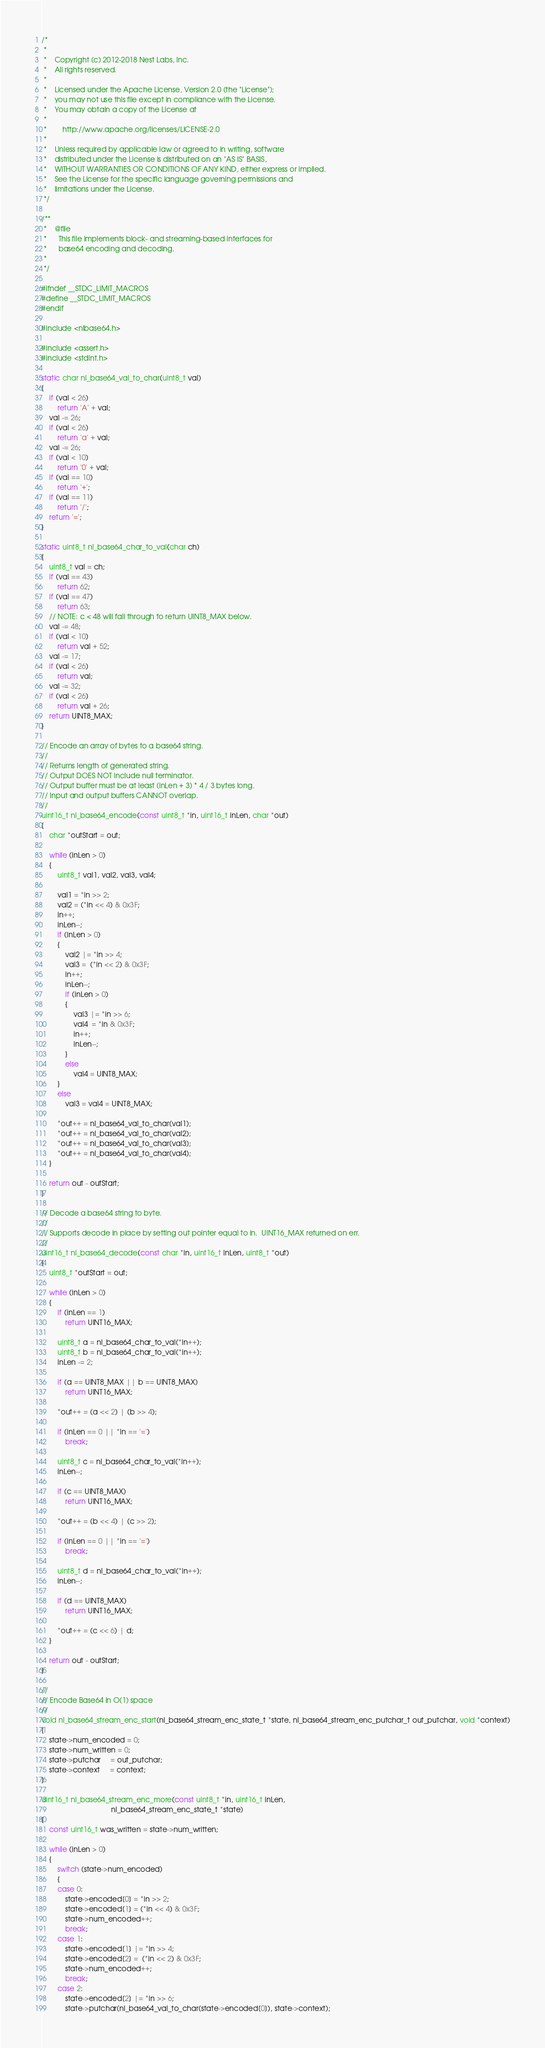Convert code to text. <code><loc_0><loc_0><loc_500><loc_500><_C_>/*
 *
 *    Copyright (c) 2012-2018 Nest Labs, Inc.
 *    All rights reserved.
 *
 *    Licensed under the Apache License, Version 2.0 (the "License");
 *    you may not use this file except in compliance with the License.
 *    You may obtain a copy of the License at
 *
 *        http://www.apache.org/licenses/LICENSE-2.0
 *
 *    Unless required by applicable law or agreed to in writing, software
 *    distributed under the License is distributed on an "AS IS" BASIS,
 *    WITHOUT WARRANTIES OR CONDITIONS OF ANY KIND, either express or implied.
 *    See the License for the specific language governing permissions and
 *    limitations under the License.
 */

/**
 *    @file
 *      This file implements block- and streaming-based interfaces for
 *      base64 encoding and decoding.
 *
 */

#ifndef __STDC_LIMIT_MACROS
#define __STDC_LIMIT_MACROS
#endif

#include <nlbase64.h>

#include <assert.h>
#include <stdint.h>

static char nl_base64_val_to_char(uint8_t val)
{
    if (val < 26)
        return 'A' + val;
    val -= 26;
    if (val < 26)
        return 'a' + val;
    val -= 26;
    if (val < 10)
        return '0' + val;
    if (val == 10)
        return '+';
    if (val == 11)
        return '/';
    return '=';
}

static uint8_t nl_base64_char_to_val(char ch)
{
    uint8_t val = ch;
    if (val == 43)
        return 62;
    if (val == 47)
        return 63;
    // NOTE: c < 48 will fall through to return UINT8_MAX below.
    val -= 48;
    if (val < 10)
        return val + 52;
    val -= 17;
    if (val < 26)
        return val;
    val -= 32;
    if (val < 26)
        return val + 26;
    return UINT8_MAX;
}

// Encode an array of bytes to a base64 string.
//
// Returns length of generated string.
// Output DOES NOT include null terminator.
// Output buffer must be at least (inLen + 3) * 4 / 3 bytes long.
// Input and output buffers CANNOT overlap.
//
uint16_t nl_base64_encode(const uint8_t *in, uint16_t inLen, char *out)
{
    char *outStart = out;

    while (inLen > 0)
    {
        uint8_t val1, val2, val3, val4;

        val1 = *in >> 2;
        val2 = (*in << 4) & 0x3F;
        in++;
        inLen--;
        if (inLen > 0)
        {
            val2 |= *in >> 4;
            val3 =  (*in << 2) & 0x3F;
            in++;
            inLen--;
            if (inLen > 0)
            {
                val3 |= *in >> 6;
                val4  = *in & 0x3F;
                in++;
                inLen--;
            }
            else
                val4 = UINT8_MAX;
        }
        else
            val3 = val4 = UINT8_MAX;

        *out++ = nl_base64_val_to_char(val1);
        *out++ = nl_base64_val_to_char(val2);
        *out++ = nl_base64_val_to_char(val3);
        *out++ = nl_base64_val_to_char(val4);
    }

    return out - outStart;
}

// Decode a base64 string to byte.
//
// Supports decode in place by setting out pointer equal to in.  UINT16_MAX returned on err.
//
uint16_t nl_base64_decode(const char *in, uint16_t inLen, uint8_t *out)
{
    uint8_t *outStart = out;

    while (inLen > 0)
    {
        if (inLen == 1)
            return UINT16_MAX;

        uint8_t a = nl_base64_char_to_val(*in++);
        uint8_t b = nl_base64_char_to_val(*in++);
        inLen -= 2;

        if (a == UINT8_MAX || b == UINT8_MAX)
            return UINT16_MAX;

        *out++ = (a << 2) | (b >> 4);

        if (inLen == 0 || *in == '=')
            break;

        uint8_t c = nl_base64_char_to_val(*in++);
        inLen--;

        if (c == UINT8_MAX)
            return UINT16_MAX;

        *out++ = (b << 4) | (c >> 2);

        if (inLen == 0 || *in == '=')
            break;

        uint8_t d = nl_base64_char_to_val(*in++);
        inLen--;

        if (d == UINT8_MAX)
            return UINT16_MAX;

        *out++ = (c << 6) | d;
    }

    return out - outStart;
}

//
// Encode Base64 in O(1) space
//
void nl_base64_stream_enc_start(nl_base64_stream_enc_state_t *state, nl_base64_stream_enc_putchar_t out_putchar, void *context)
{
    state->num_encoded = 0;
    state->num_written = 0;
    state->putchar     = out_putchar;
    state->context     = context;
}

uint16_t nl_base64_stream_enc_more(const uint8_t *in, uint16_t inLen,
                                   nl_base64_stream_enc_state_t *state)
{
    const uint16_t was_written = state->num_written;

    while (inLen > 0)
    {
        switch (state->num_encoded)
        {
        case 0:
            state->encoded[0] = *in >> 2;
            state->encoded[1] = (*in << 4) & 0x3F;
            state->num_encoded++;
            break;
        case 1:
            state->encoded[1] |= *in >> 4;
            state->encoded[2] =  (*in << 2) & 0x3F;
            state->num_encoded++;
            break;
        case 2:
            state->encoded[2] |= *in >> 6;
            state->putchar(nl_base64_val_to_char(state->encoded[0]), state->context);</code> 